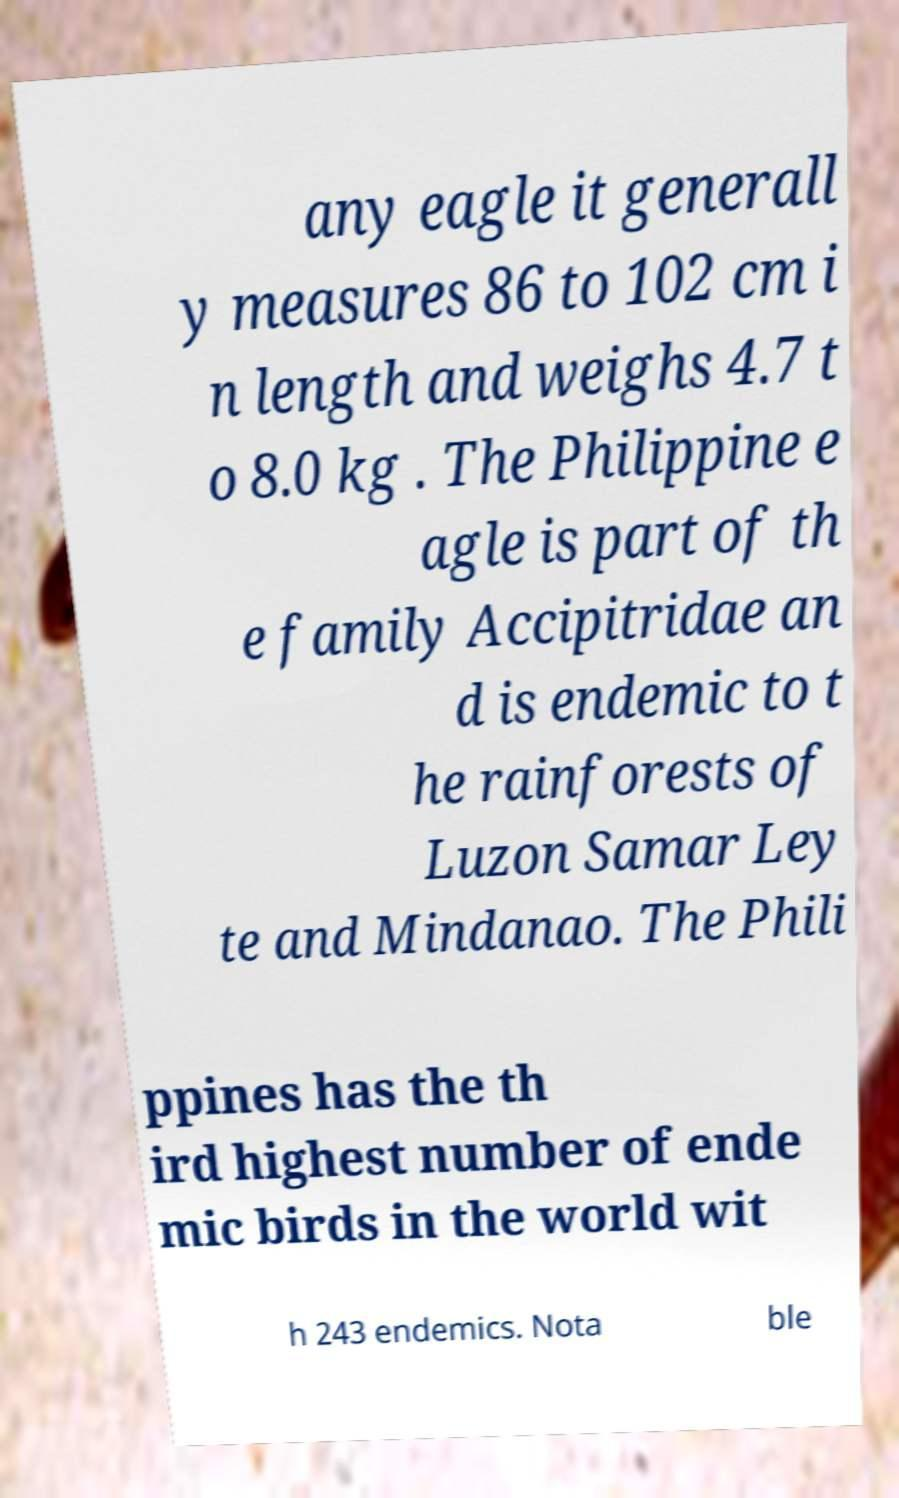Could you extract and type out the text from this image? any eagle it generall y measures 86 to 102 cm i n length and weighs 4.7 t o 8.0 kg . The Philippine e agle is part of th e family Accipitridae an d is endemic to t he rainforests of Luzon Samar Ley te and Mindanao. The Phili ppines has the th ird highest number of ende mic birds in the world wit h 243 endemics. Nota ble 